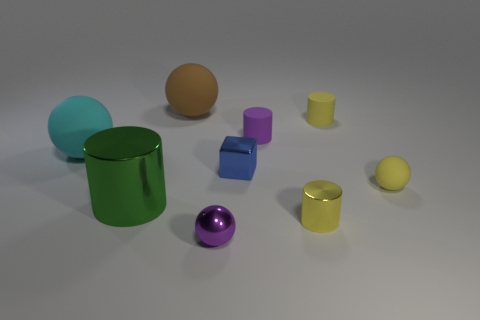Subtract all cyan spheres. How many spheres are left? 3 Add 1 small blue metal cylinders. How many objects exist? 10 Subtract all cyan spheres. How many spheres are left? 3 Subtract 2 balls. How many balls are left? 2 Subtract all blue cylinders. How many purple balls are left? 1 Add 8 small yellow matte balls. How many small yellow matte balls are left? 9 Add 9 yellow metallic cubes. How many yellow metallic cubes exist? 9 Subtract 0 purple cubes. How many objects are left? 9 Subtract all blocks. How many objects are left? 8 Subtract all gray balls. Subtract all green cubes. How many balls are left? 4 